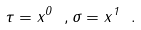<formula> <loc_0><loc_0><loc_500><loc_500>\tau = x ^ { 0 } \ , \sigma = x ^ { 1 } \ .</formula> 